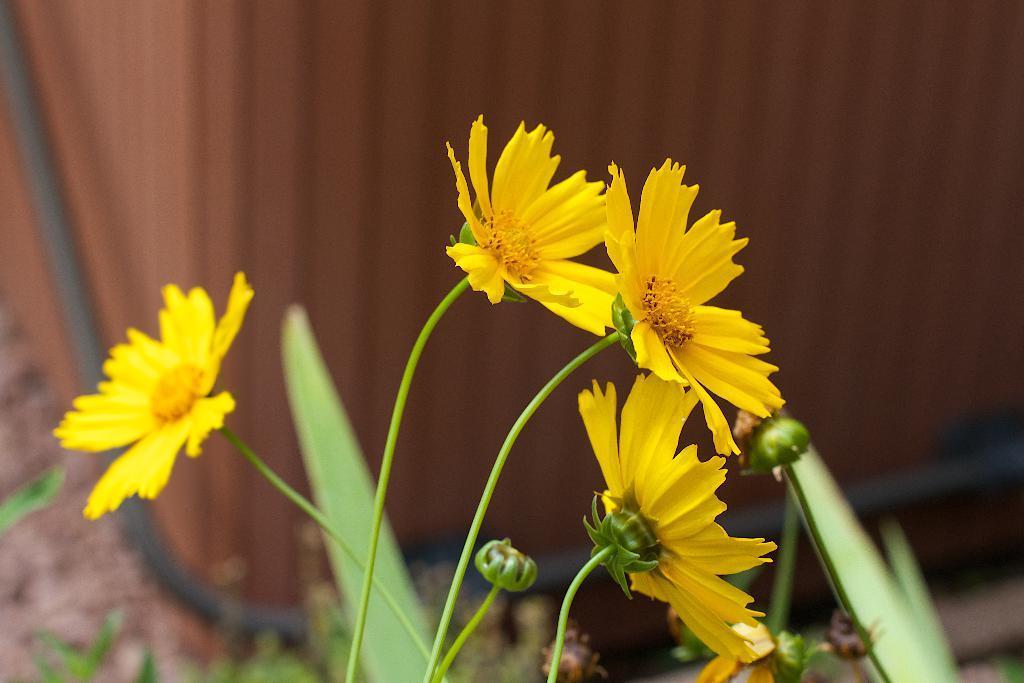Describe this image in one or two sentences. In this image there are a few flowers with stems. 